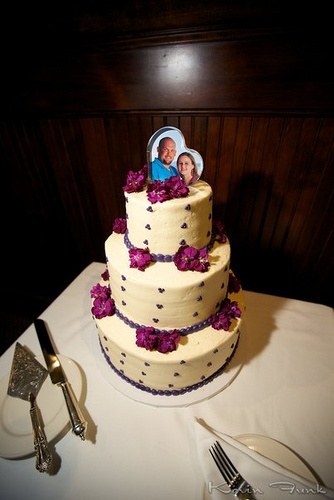Describe the objects in this image and their specific colors. I can see dining table in black, darkgray, tan, and gray tones, cake in black, tan, beige, and maroon tones, cake in black, tan, and beige tones, knife in black, gray, and tan tones, and people in black, teal, maroon, and brown tones in this image. 